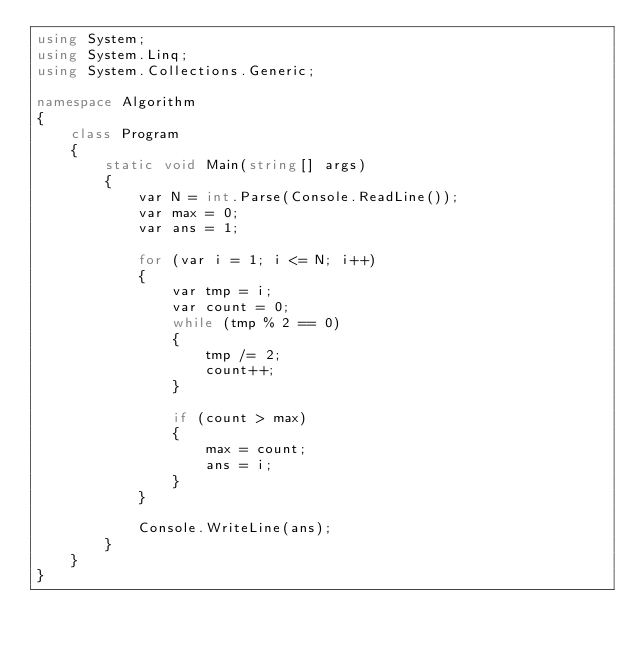Convert code to text. <code><loc_0><loc_0><loc_500><loc_500><_C#_>using System;
using System.Linq;
using System.Collections.Generic;

namespace Algorithm
{
    class Program
    {
        static void Main(string[] args)
        {
            var N = int.Parse(Console.ReadLine());
            var max = 0;
            var ans = 1;

            for (var i = 1; i <= N; i++)
            {
                var tmp = i;
                var count = 0;
                while (tmp % 2 == 0)
                {
                    tmp /= 2;
                    count++;
                }

                if (count > max)
                {
                    max = count;
                    ans = i;
                }
            }

            Console.WriteLine(ans);
        }
    }
}
</code> 